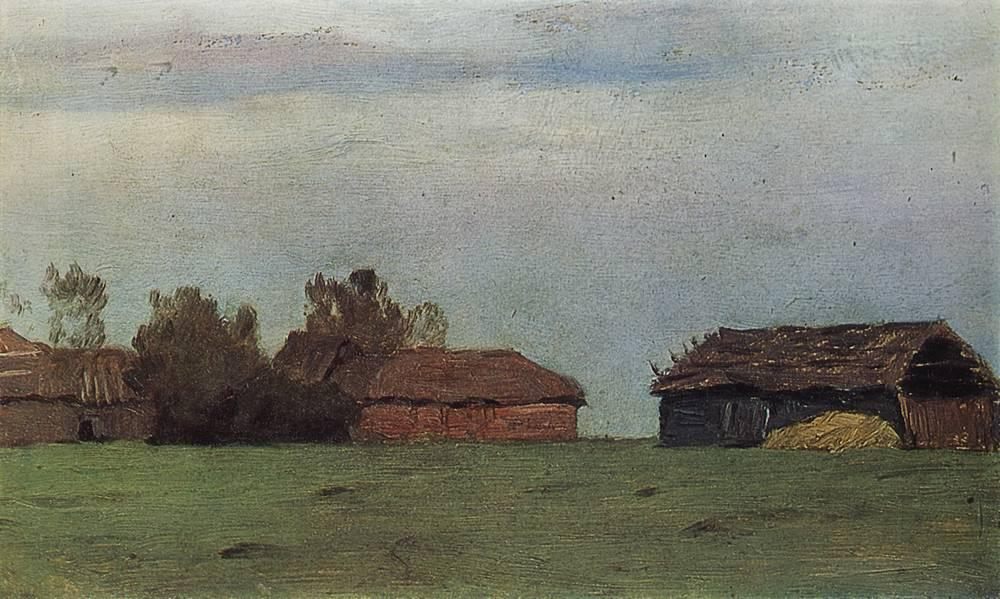If these buildings could talk, what stories might they tell? If these buildings could talk, they might recount stories of hardworking farmers and their daily routines, from early morning chores to late-night preparations for the coming seasons. They might share memories of children playing in the fields and families gathering for meals. They could tell of harsh winters and bountiful harvests, of neighbors coming together in times of need. Each wall and beam would hold echoes of laughter, struggle, and perseverance, painting a vivid picture of rural life over the decades. Do you think there is any wildlife around these buildings right now? Given the serene and somewhat secluded nature of the landscape, it's quite likely that various forms of wildlife inhabit the area. Birds might nest in the eaves of the old buildings, and small mammals such as rabbits and foxes could be sheltering in the fields. The rich vegetation suggests that insects and other small creatures thrive here, contributing to a delicate ecosystem that quietly coexists with the remnants of human activity. 